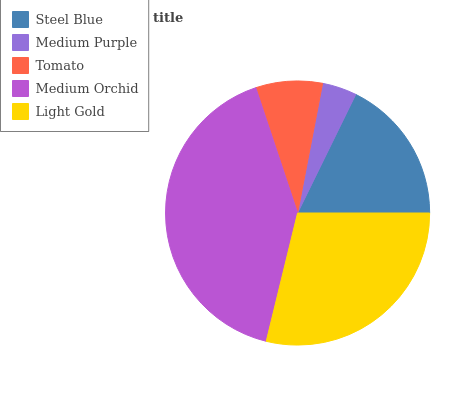Is Medium Purple the minimum?
Answer yes or no. Yes. Is Medium Orchid the maximum?
Answer yes or no. Yes. Is Tomato the minimum?
Answer yes or no. No. Is Tomato the maximum?
Answer yes or no. No. Is Tomato greater than Medium Purple?
Answer yes or no. Yes. Is Medium Purple less than Tomato?
Answer yes or no. Yes. Is Medium Purple greater than Tomato?
Answer yes or no. No. Is Tomato less than Medium Purple?
Answer yes or no. No. Is Steel Blue the high median?
Answer yes or no. Yes. Is Steel Blue the low median?
Answer yes or no. Yes. Is Light Gold the high median?
Answer yes or no. No. Is Light Gold the low median?
Answer yes or no. No. 